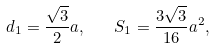<formula> <loc_0><loc_0><loc_500><loc_500>d _ { 1 } = \frac { \sqrt { 3 } } { 2 } a , \quad S _ { 1 } = \frac { 3 \sqrt { 3 } } { 1 6 } a ^ { 2 } ,</formula> 